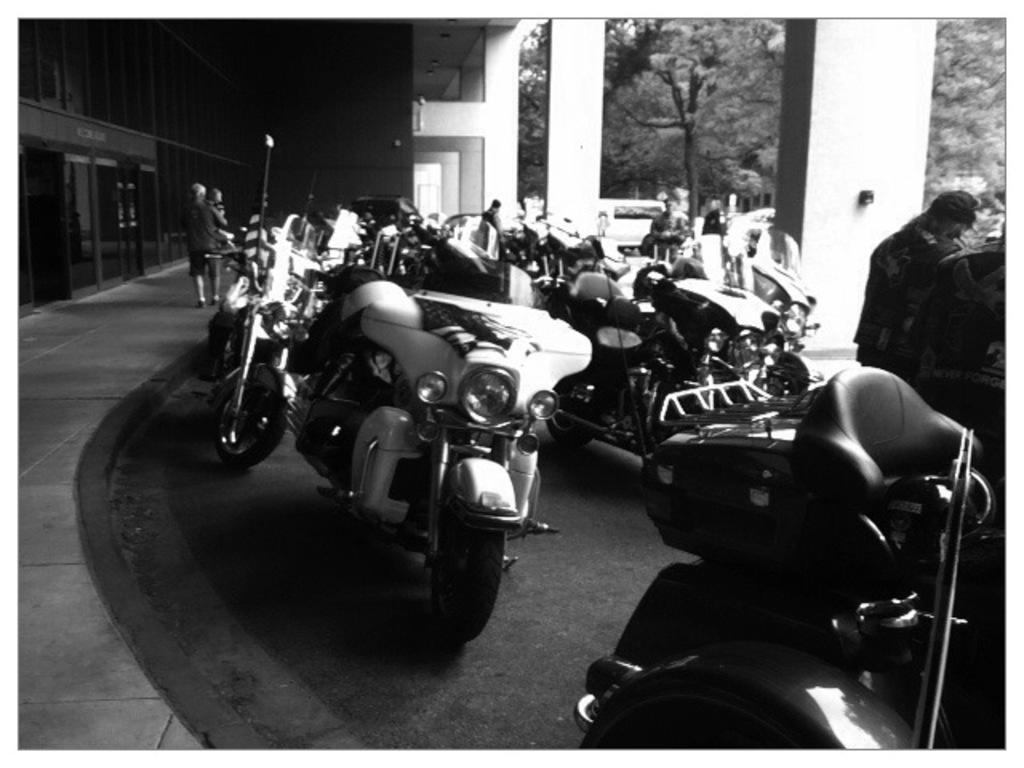In one or two sentences, can you explain what this image depicts? In the picture we can see a number of bikes are parked on the path and on the right hand side we can see some pillars and to the left hand side we can see a building wall with a door and in the background we can see some trees, and some people standing and talking. 